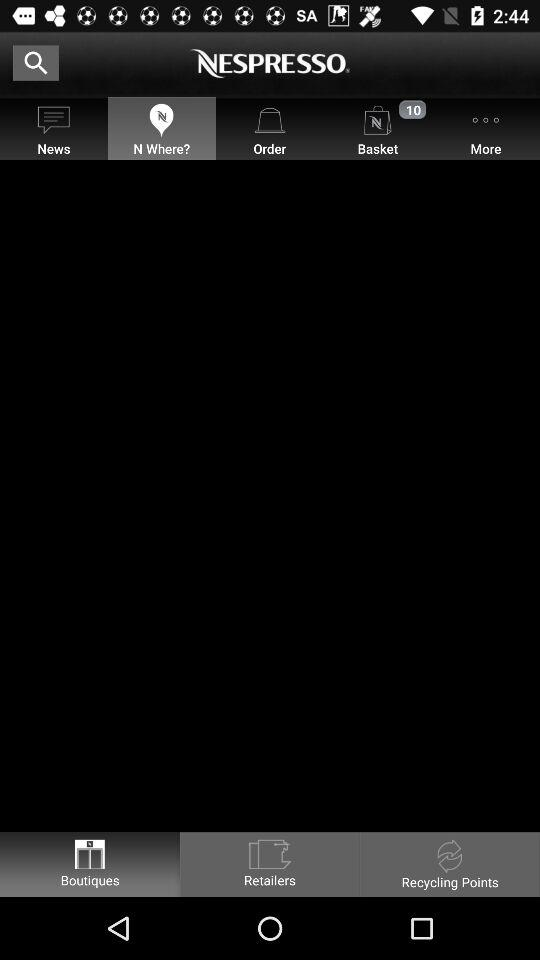What is the application name? The application name is "NESPRESSO". 